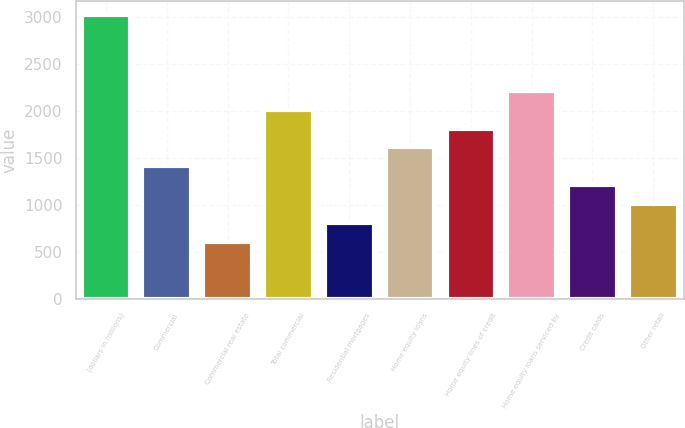Convert chart to OTSL. <chart><loc_0><loc_0><loc_500><loc_500><bar_chart><fcel>(dollars in millions)<fcel>Commercial<fcel>Commercial real estate<fcel>Total commercial<fcel>Residential mortgages<fcel>Home equity loans<fcel>Home equity lines of credit<fcel>Home equity loans serviced by<fcel>Credit cards<fcel>Other retail<nl><fcel>3017<fcel>1410.6<fcel>607.4<fcel>2013<fcel>808.2<fcel>1611.4<fcel>1812.2<fcel>2213.8<fcel>1209.8<fcel>1009<nl></chart> 